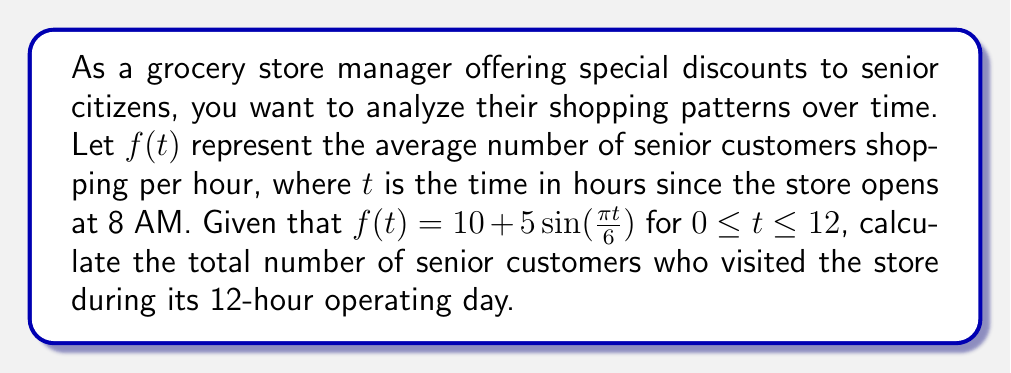Teach me how to tackle this problem. To find the total number of senior customers who visited the store during the 12-hour operating day, we need to integrate the function $f(t)$ over the interval $[0, 12]$.

Step 1: Set up the integral
$$\int_0^{12} f(t) dt = \int_0^{12} (10 + 5\sin(\frac{\pi t}{6})) dt$$

Step 2: Split the integral
$$\int_0^{12} 10 dt + \int_0^{12} 5\sin(\frac{\pi t}{6}) dt$$

Step 3: Evaluate the first integral
$$10t \bigg|_0^{12} = 120$$

Step 4: Evaluate the second integral using substitution
Let $u = \frac{\pi t}{6}$, then $du = \frac{\pi}{6} dt$ and $dt = \frac{6}{\pi} du$

$$5 \cdot \frac{6}{\pi} \int_0^{2\pi} \sin(u) du = \frac{30}{\pi} [-\cos(u)]_0^{2\pi} = \frac{30}{\pi} [(-\cos(2\pi)) - (-\cos(0))] = 0$$

Step 5: Sum the results
Total = 120 + 0 = 120

Therefore, the total number of senior customers who visited the store during its 12-hour operating day is 120.
Answer: 120 senior customers 